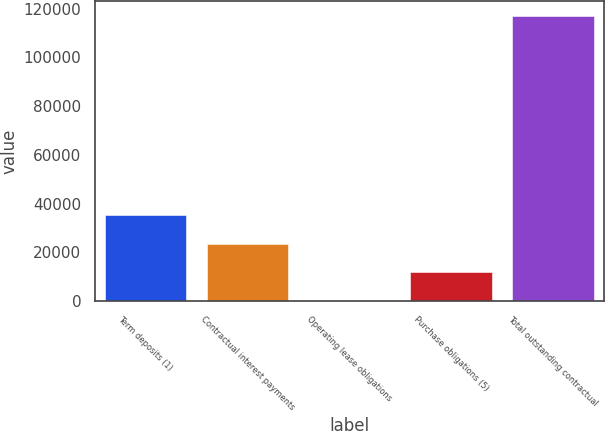Convert chart to OTSL. <chart><loc_0><loc_0><loc_500><loc_500><bar_chart><fcel>Term deposits (1)<fcel>Contractual interest payments<fcel>Operating lease obligations<fcel>Purchase obligations (5)<fcel>Total outstanding contractual<nl><fcel>35249.4<fcel>23554.6<fcel>165<fcel>11859.8<fcel>117113<nl></chart> 